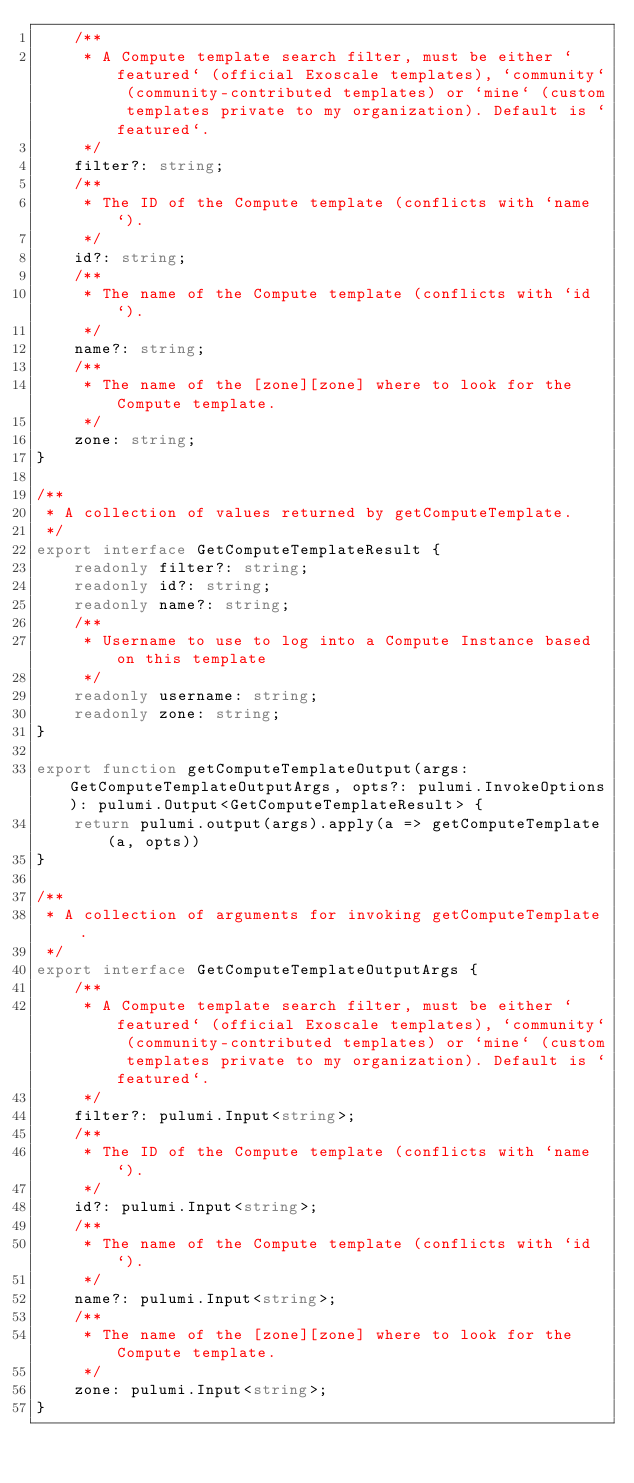<code> <loc_0><loc_0><loc_500><loc_500><_TypeScript_>    /**
     * A Compute template search filter, must be either `featured` (official Exoscale templates), `community` (community-contributed templates) or `mine` (custom templates private to my organization). Default is `featured`.
     */
    filter?: string;
    /**
     * The ID of the Compute template (conflicts with `name`).
     */
    id?: string;
    /**
     * The name of the Compute template (conflicts with `id`).
     */
    name?: string;
    /**
     * The name of the [zone][zone] where to look for the Compute template.
     */
    zone: string;
}

/**
 * A collection of values returned by getComputeTemplate.
 */
export interface GetComputeTemplateResult {
    readonly filter?: string;
    readonly id?: string;
    readonly name?: string;
    /**
     * Username to use to log into a Compute Instance based on this template
     */
    readonly username: string;
    readonly zone: string;
}

export function getComputeTemplateOutput(args: GetComputeTemplateOutputArgs, opts?: pulumi.InvokeOptions): pulumi.Output<GetComputeTemplateResult> {
    return pulumi.output(args).apply(a => getComputeTemplate(a, opts))
}

/**
 * A collection of arguments for invoking getComputeTemplate.
 */
export interface GetComputeTemplateOutputArgs {
    /**
     * A Compute template search filter, must be either `featured` (official Exoscale templates), `community` (community-contributed templates) or `mine` (custom templates private to my organization). Default is `featured`.
     */
    filter?: pulumi.Input<string>;
    /**
     * The ID of the Compute template (conflicts with `name`).
     */
    id?: pulumi.Input<string>;
    /**
     * The name of the Compute template (conflicts with `id`).
     */
    name?: pulumi.Input<string>;
    /**
     * The name of the [zone][zone] where to look for the Compute template.
     */
    zone: pulumi.Input<string>;
}
</code> 